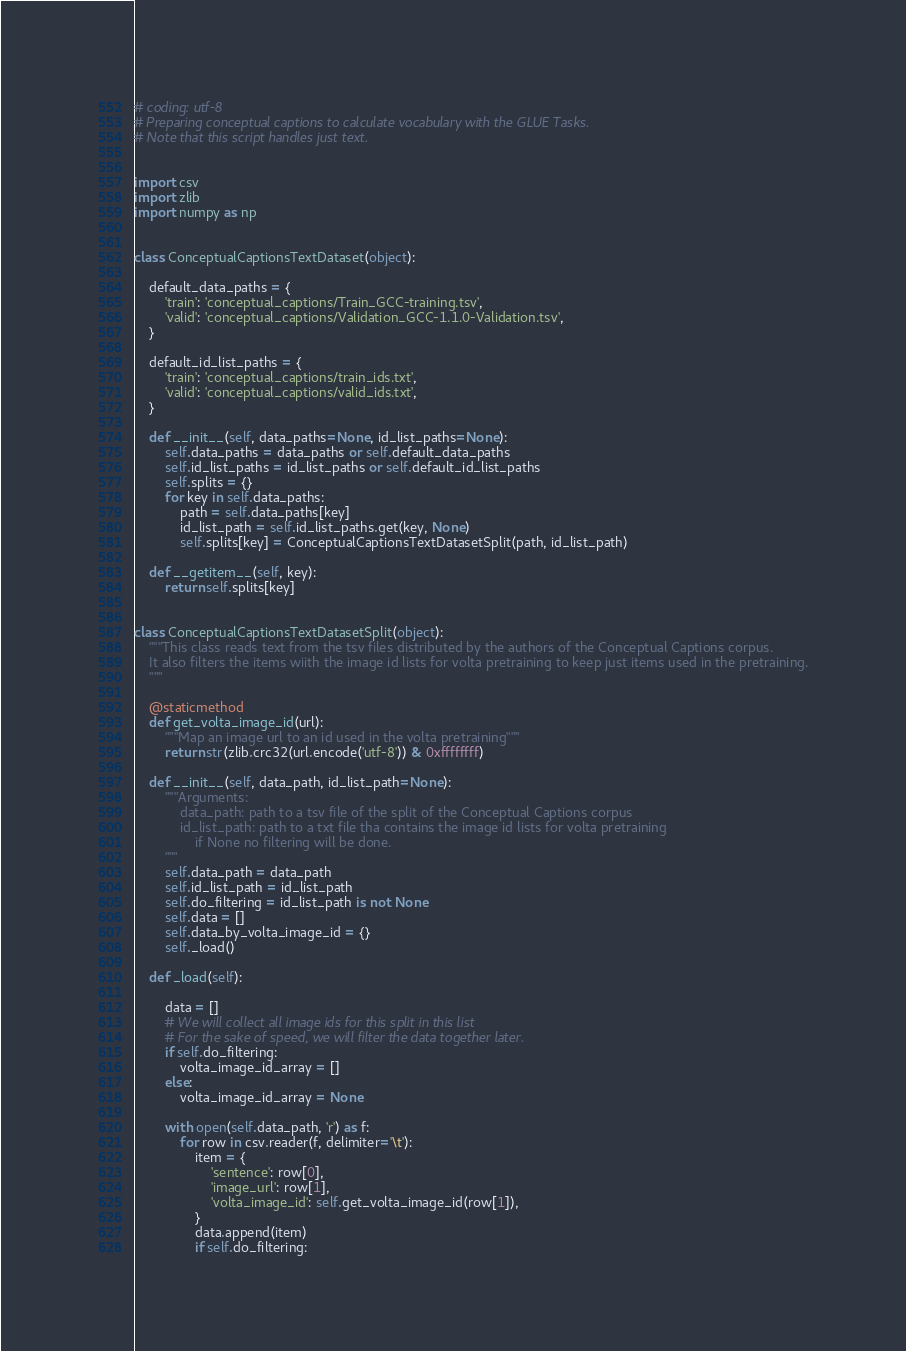<code> <loc_0><loc_0><loc_500><loc_500><_Python_># coding: utf-8
# Preparing conceptual captions to calculate vocabulary with the GLUE Tasks.
# Note that this script handles just text.


import csv
import zlib
import numpy as np


class ConceptualCaptionsTextDataset(object):
    
    default_data_paths = {
        'train': 'conceptual_captions/Train_GCC-training.tsv',
        'valid': 'conceptual_captions/Validation_GCC-1.1.0-Validation.tsv',
    }
    
    default_id_list_paths = {
        'train': 'conceptual_captions/train_ids.txt',
        'valid': 'conceptual_captions/valid_ids.txt',
    }
    
    def __init__(self, data_paths=None, id_list_paths=None):
        self.data_paths = data_paths or self.default_data_paths
        self.id_list_paths = id_list_paths or self.default_id_list_paths
        self.splits = {}
        for key in self.data_paths:
            path = self.data_paths[key]
            id_list_path = self.id_list_paths.get(key, None)
            self.splits[key] = ConceptualCaptionsTextDatasetSplit(path, id_list_path)
    
    def __getitem__(self, key):
        return self.splits[key]


class ConceptualCaptionsTextDatasetSplit(object):
    """This class reads text from the tsv files distributed by the authors of the Conceptual Captions corpus.
    It also filters the items wiith the image id lists for volta pretraining to keep just items used in the pretraining.
    """
    
    @staticmethod
    def get_volta_image_id(url):
        """Map an image url to an id used in the volta pretraining"""
        return str(zlib.crc32(url.encode('utf-8')) & 0xffffffff)
    
    def __init__(self, data_path, id_list_path=None):
        """Arguments:
            data_path: path to a tsv file of the split of the Conceptual Captions corpus
            id_list_path: path to a txt file tha contains the image id lists for volta pretraining
                if None no filtering will be done.
        """
        self.data_path = data_path
        self.id_list_path = id_list_path
        self.do_filtering = id_list_path is not None
        self.data = []
        self.data_by_volta_image_id = {}
        self._load()
    
    def _load(self):
        
        data = []
        # We will collect all image ids for this split in this list
        # For the sake of speed, we will filter the data together later.
        if self.do_filtering:
            volta_image_id_array = []
        else:
            volta_image_id_array = None
        
        with open(self.data_path, 'r') as f:
            for row in csv.reader(f, delimiter='\t'):
                item = {
                    'sentence': row[0], 
                    'image_url': row[1], 
                    'volta_image_id': self.get_volta_image_id(row[1]),
                }
                data.append(item)
                if self.do_filtering:</code> 